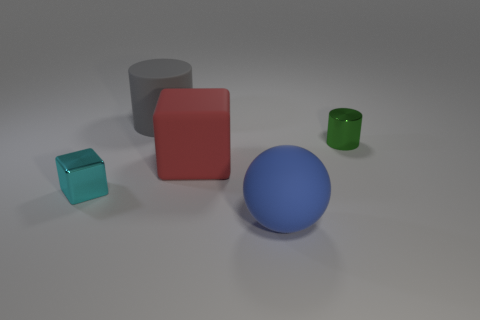How many things are either tiny blue cubes or spheres?
Your answer should be compact. 1. There is a shiny thing right of the object in front of the cube that is on the left side of the large gray matte cylinder; how big is it?
Your answer should be very brief. Small. What number of rubber objects have the same color as the tiny metal block?
Keep it short and to the point. 0. What number of things have the same material as the green cylinder?
Offer a terse response. 1. How many objects are either small green balls or small things that are to the right of the gray cylinder?
Make the answer very short. 1. There is a small object in front of the small metal thing that is on the right side of the gray rubber thing on the left side of the big cube; what color is it?
Provide a succinct answer. Cyan. What size is the matte object behind the small metal cylinder?
Offer a terse response. Large. How many small things are red cubes or green shiny cylinders?
Your answer should be compact. 1. There is a rubber thing that is both to the right of the big gray thing and behind the small cyan object; what color is it?
Give a very brief answer. Red. Are there any big blue things that have the same shape as the large gray thing?
Make the answer very short. No. 